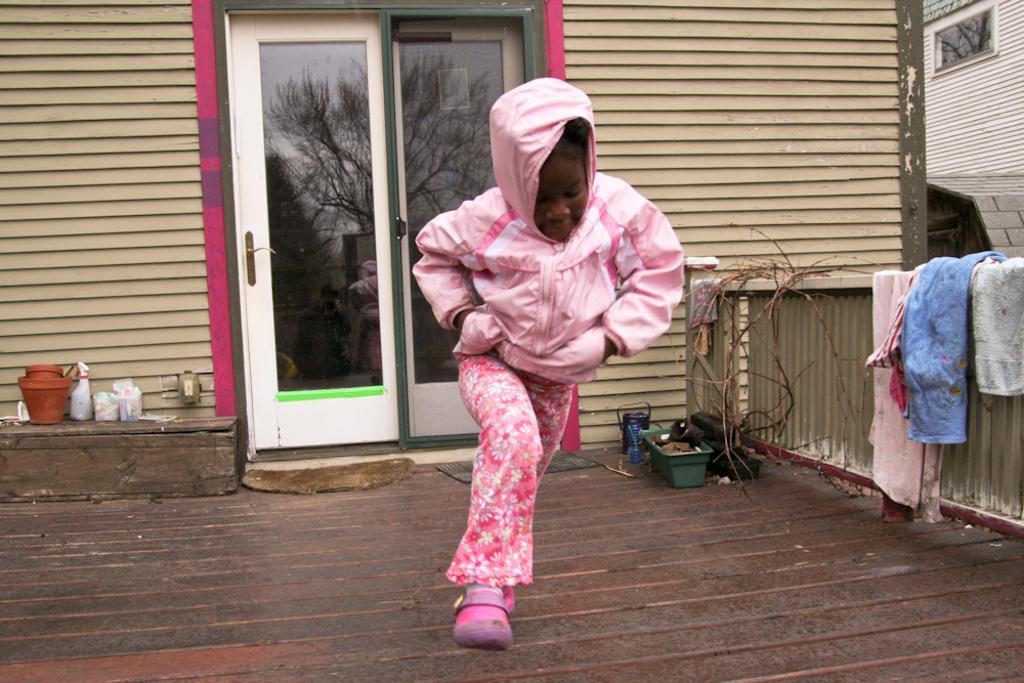How would you summarize this image in a sentence or two? In this image I can see a child wearing a jacket and standing on the ground. On the right side there is wall on which there are few clothes. Beside the wall there are few objects placed on the ground. In the background there is a building and I can see two glass doors. On the left side there is a pot and some other objects. 